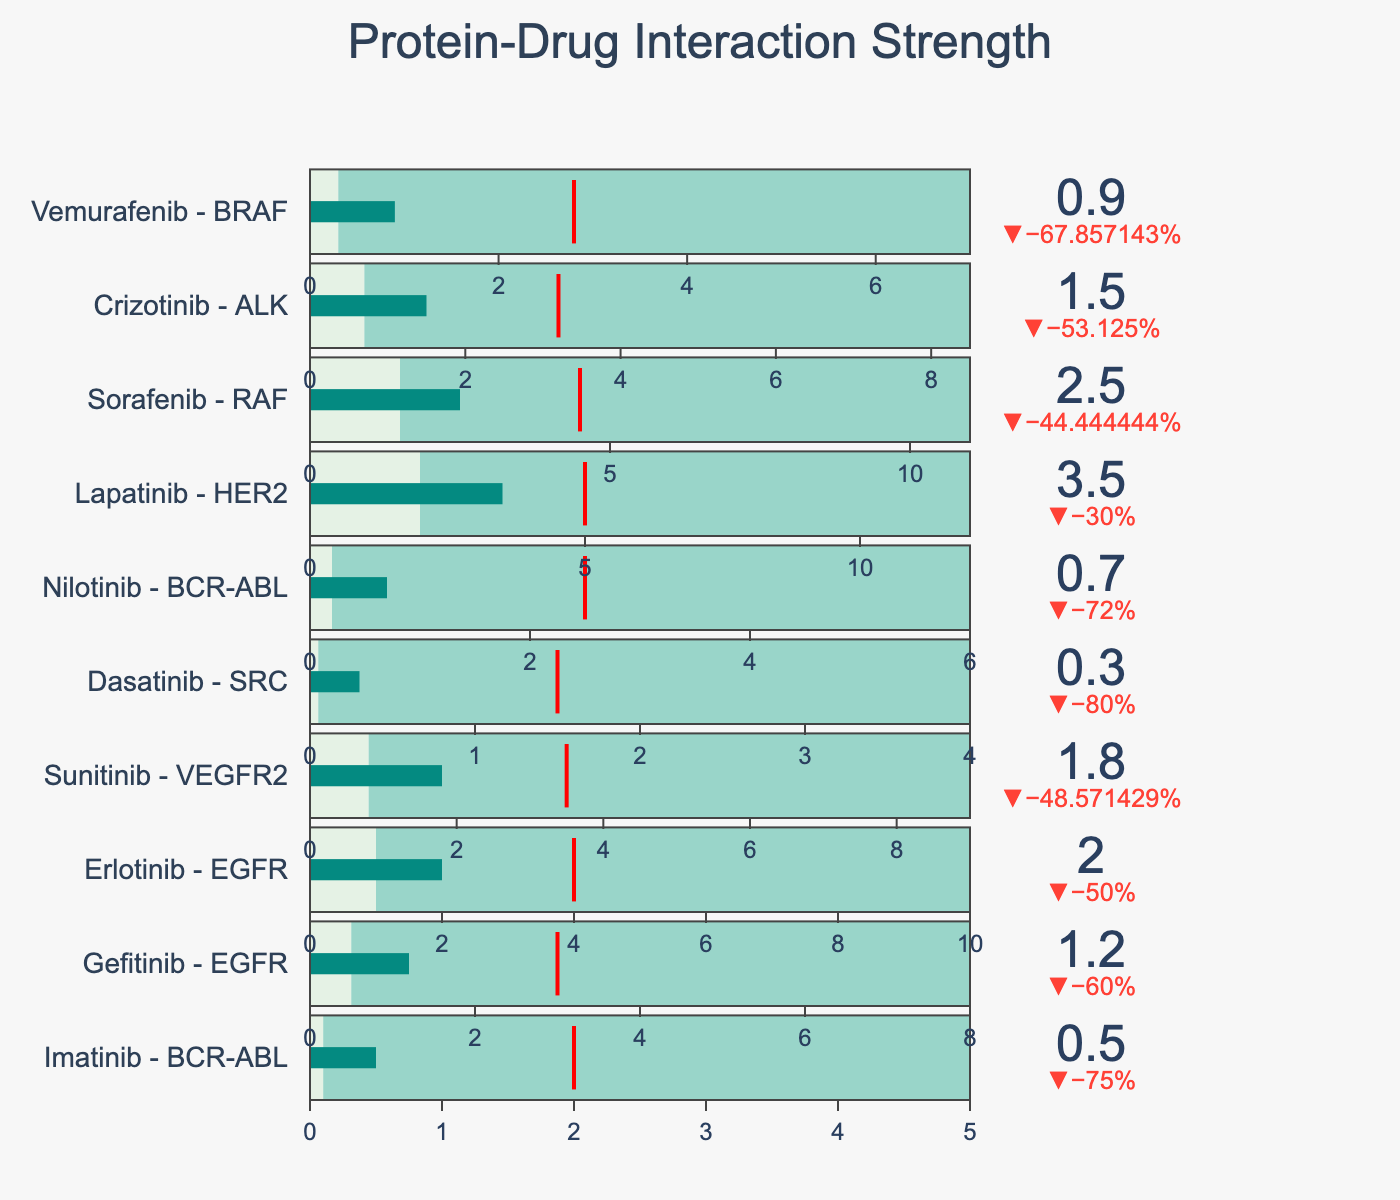What is the value of the binding affinity for Imatinib? The binding affinity value can be read directly from the chart next to the label for Imatinib.
Answer: 0.5 nM Which compound has the lowest binding affinity? By looking at the bullet chart, Dasatinib has the lowest binding affinity value, as its bar fills the least amount compared to others.
Answer: Dasatinib What is the difference between the binding affinity of Imatinib and Gefitinib? Subtract the binding affinity value of Gefitinib (1.2 nM) from Imatinib (0.5 nM): \( \text{0.5 nM} - \text{1.2 nM} = \text{-0.7 nM} \).
Answer: -0.7 nM Which compound-target pair has the highest mean affinity? Observe the mean affinity values marked by red lines. Lapatinib - HER2 has the highest mean affinity with a value of 5.0 nM.
Answer: Lapatinib - HER2 What is the range of the binding affinity for Sorafenib? The minimum affinity is 1.5 nM, and the maximum affinity is 11.0 nM, so the range is \( \text{11.0 nM} - \text{1.5 nM} = \text{9.5 nM} \).
Answer: 9.5 nM How does Vemurafenib's binding affinity compare to its mean affinity? Vemurafenib's binding affinity is 0.9 nM, and the mean affinity is 2.8 nM. Since \( \text{0.9 nM} < \text{2.8 nM} \), Vemurafenib's binding affinity is lower than its mean affinity.
Answer: Lower Which compound has a binding affinity closest to its mean affinity? Calculate the difference between binding affinity and mean affinity for each compound. Dasatinib has the smallest difference, 0.3 nM binding affinity vs mean affinity of 1.5 nM \( ( \text{difference} = \text{1.2 nM} ) \), being the closest.
Answer: Dasatinib Identify the compound with the widest range of binding affinities. The range is calculated by subtracting the minimum value from the maximum value. Lapatinib has the widest range \( \text{12.0 nM} - \text{2.0 nM} = \text{10.0 nM} \).
Answer: Lapatinib Which target has the most compounds with binding affinities represented in the chart? Count the compounds for each target: BCR-ABL (2), EGFR (2), VEGFR2 (1), SRC (1), HER2 (1), RAF (1), ALK (1), BRAF (1). BCR-ABL and EGFR each have two compounds.
Answer: BCR-ABL and EGFR 